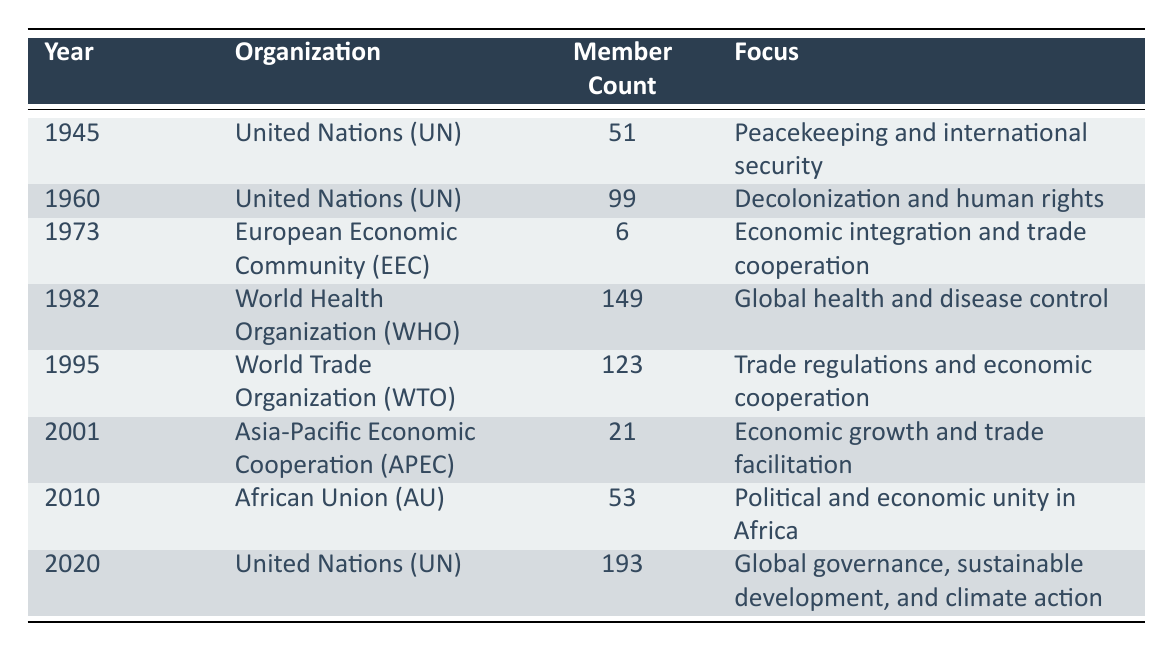What was the member count of the United Nations in 1960? Referring to the table, in the row for the year 1960 under the organization United Nations, the member count is listed as 99.
Answer: 99 How many members did the European Economic Community have in 1973? According to the table, the European Economic Community had a member count of 6 in 1973.
Answer: 6 What is the total member count of the World Health Organization in 1982 and the World Trade Organization in 1995? To find the total, we add the member counts: 149 (WHO, 1982) + 123 (WTO, 1995) = 272.
Answer: 272 Did the United Nations increase or decrease its membership from 1945 to 2020? The member count in 1945 was 51, and by 2020 it was 193. Since 193 is greater than 51, the membership increased.
Answer: Yes Which organization had the highest member count in 2020? The United Nations is listed in the year 2020 with a member count of 193, which is the highest compared to other organizations listed.
Answer: United Nations What was the focus of the African Union in 2010? Looking at the row for the African Union in 2010, it states that its focus was on political and economic unity in Africa.
Answer: Political and economic unity in Africa What is the average member count across all organizations listed in the table? We first sum all the member counts: 51 + 99 + 6 + 149 + 123 + 21 + 53 + 193 = 695. There are 8 organizations, therefore the average is 695/8 = 86.875.
Answer: 86.875 How many organizations mentioned in the table focused on economic integration or cooperation? The organizations with an economic focus are the European Economic Community (1973), World Trade Organization (1995), and Asia-Pacific Economic Cooperation (2001). This gives a total of 3 organizations.
Answer: 3 What was the change in focus of the United Nations from 1960 to 2020? In 1960, the UN's focus was on decolonization and human rights, while in 2020 it evolved to global governance, sustainable development, and climate action, indicating a shift towards more comprehensive global issues.
Answer: Shifted focus to broader global issues 